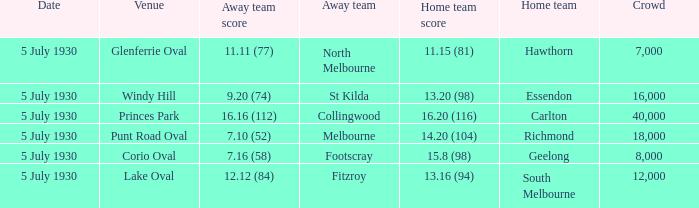What day does the team play at punt road oval? 5 July 1930. Could you parse the entire table? {'header': ['Date', 'Venue', 'Away team score', 'Away team', 'Home team score', 'Home team', 'Crowd'], 'rows': [['5 July 1930', 'Glenferrie Oval', '11.11 (77)', 'North Melbourne', '11.15 (81)', 'Hawthorn', '7,000'], ['5 July 1930', 'Windy Hill', '9.20 (74)', 'St Kilda', '13.20 (98)', 'Essendon', '16,000'], ['5 July 1930', 'Princes Park', '16.16 (112)', 'Collingwood', '16.20 (116)', 'Carlton', '40,000'], ['5 July 1930', 'Punt Road Oval', '7.10 (52)', 'Melbourne', '14.20 (104)', 'Richmond', '18,000'], ['5 July 1930', 'Corio Oval', '7.16 (58)', 'Footscray', '15.8 (98)', 'Geelong', '8,000'], ['5 July 1930', 'Lake Oval', '12.12 (84)', 'Fitzroy', '13.16 (94)', 'South Melbourne', '12,000']]} 